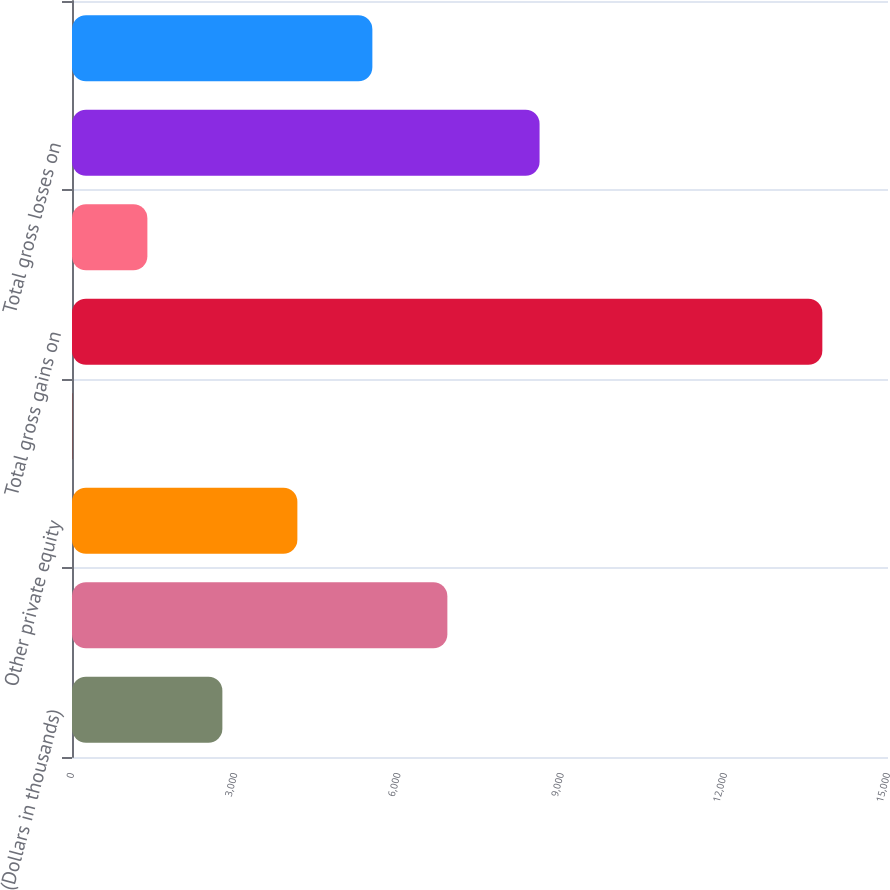Convert chart. <chart><loc_0><loc_0><loc_500><loc_500><bar_chart><fcel>(Dollars in thousands)<fcel>Venture capital fund<fcel>Other private equity<fcel>Other investments<fcel>Total gross gains on<fcel>Available-for-sale securities<fcel>Total gross losses on<fcel>Gains (losses) on investment<nl><fcel>2764.2<fcel>6900<fcel>4142.8<fcel>7<fcel>13793<fcel>1385.6<fcel>8595<fcel>5521.4<nl></chart> 